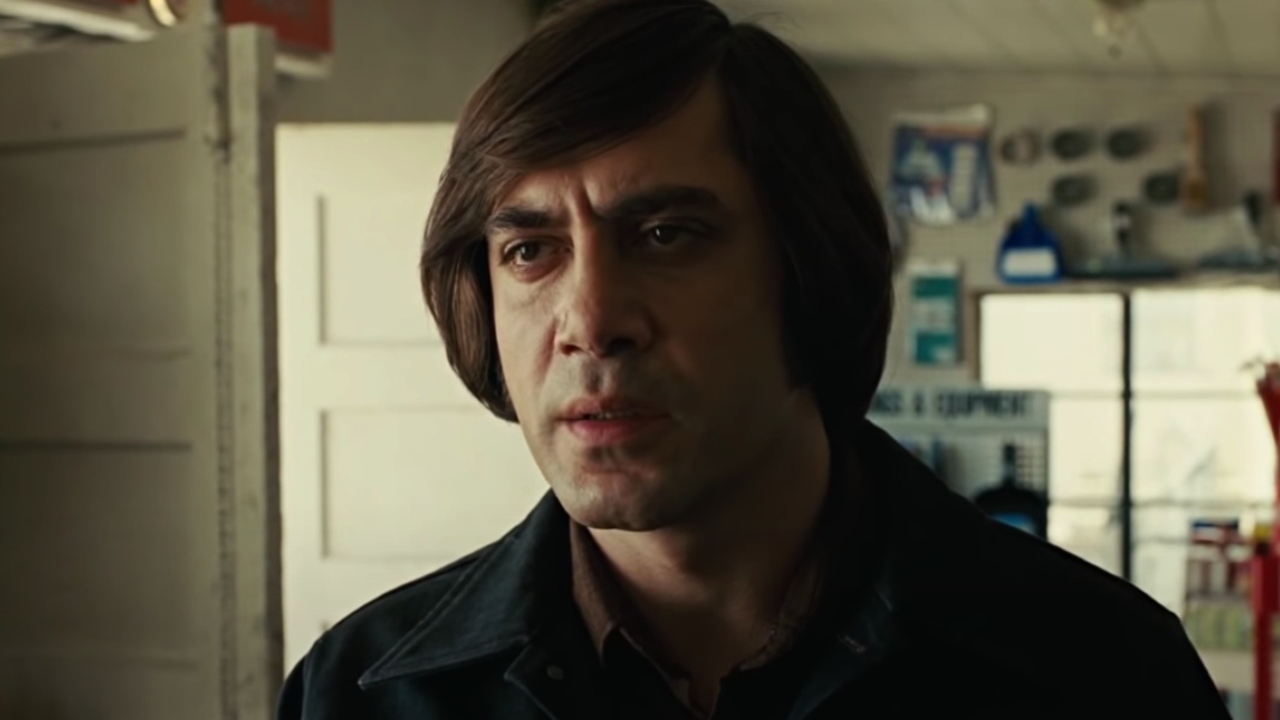How might the character's surroundings influence his thoughts and emotions? The workshop setting plays a significant role in shaping the character's thoughts and emotions. Surrounded by tools and equipment, he is constantly reminded of his life's work and the challenges it entails. The cluttered yet familiar environment provides a sense of purpose and continuity, though it might also amplify his feelings of being trapped in a cycle of difficult choices and hard labor. The balance between the practical elements of his surroundings and the weight of his responsibilities creates a complex emotional landscape. What kind of relationship might he have with the tools in his workshop? The character likely has a deep, almost personal relationship with the tools in his workshop. Each tool might carry a story of a job well done or a lesson learned the hard way. For him, these tools are more than just instruments; they are trusted companions in his daily battles. The wear and tear on each one tell tales of perseverance and dedication, making them integral to both his identity and his sense of purpose. Imagine an extremely creative scenario: What if the tools in the workshop were sentient and could communicate with him? In an imaginative twist, the tools in the workshop are sentient and capable of communication. Each tool, with its unique personality, offers advice and support. The wrench, wise and reliable, often shares stories of past repairs gone wrong, while the hammer, brash and bold, encourages quick and decisive action. The character finds solace in their conversations, knowing he's never truly alone. As he grapples with complex problems, the tools debate and collaborate, offering him a multitude of perspectives. This fantastical relationship not only enriches his daily routine but also provides him with unconventional solutions that he wouldn’t conceive on his own. 